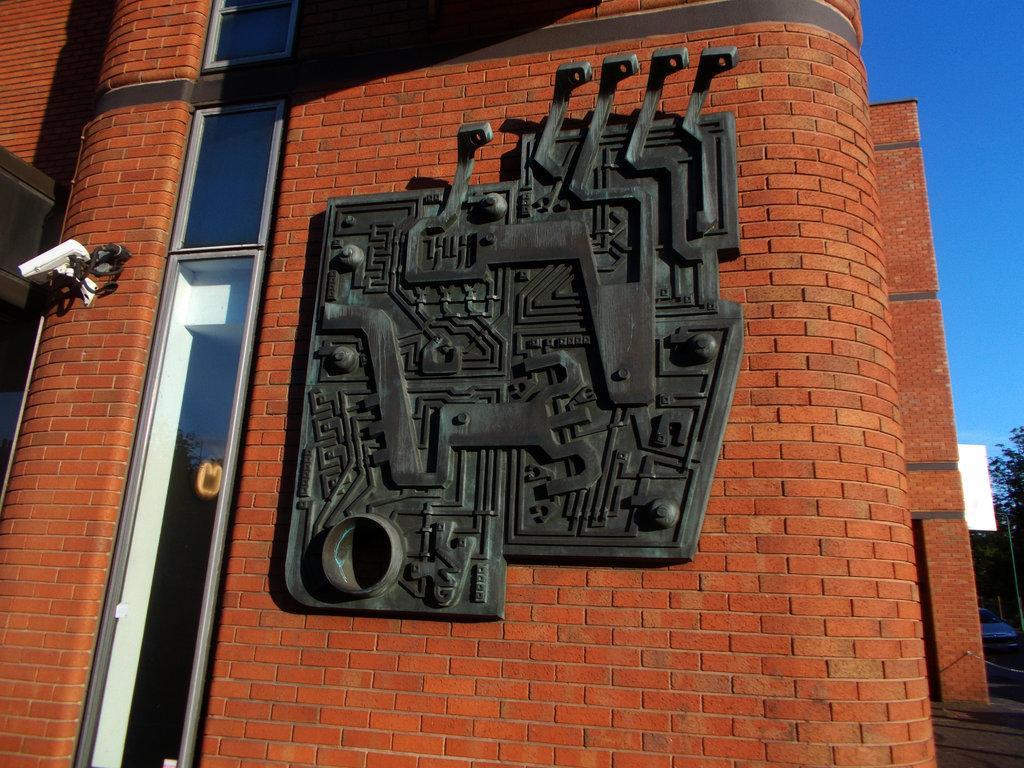Please provide a concise description of this image. In this image we can see a building, glasses, trees, and few objects. On the right side of the image we can see sky. 